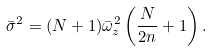<formula> <loc_0><loc_0><loc_500><loc_500>\bar { \sigma } ^ { 2 } = ( N + 1 ) \bar { \omega } _ { z } ^ { 2 } \left ( \frac { N } { 2 n } + 1 \right ) .</formula> 